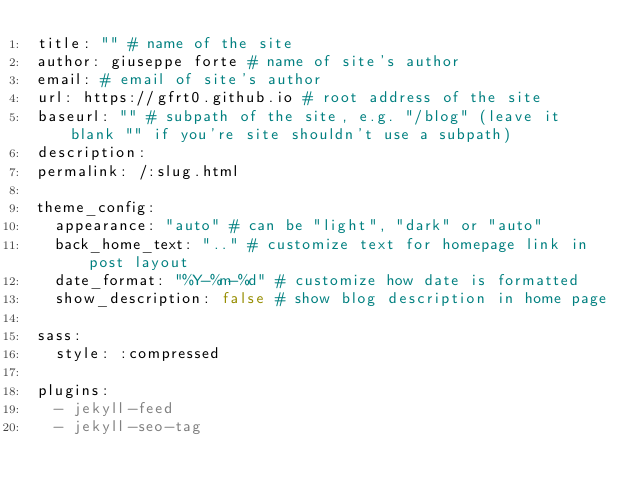<code> <loc_0><loc_0><loc_500><loc_500><_YAML_>title: "" # name of the site
author: giuseppe forte # name of site's author
email: # email of site's author
url: https://gfrt0.github.io # root address of the site
baseurl: "" # subpath of the site, e.g. "/blog" (leave it blank "" if you're site shouldn't use a subpath)
description: 
permalink: /:slug.html

theme_config:
  appearance: "auto" # can be "light", "dark" or "auto"
  back_home_text: ".." # customize text for homepage link in post layout
  date_format: "%Y-%m-%d" # customize how date is formatted
  show_description: false # show blog description in home page

sass:
  style: :compressed

plugins:
  - jekyll-feed
  - jekyll-seo-tag
</code> 